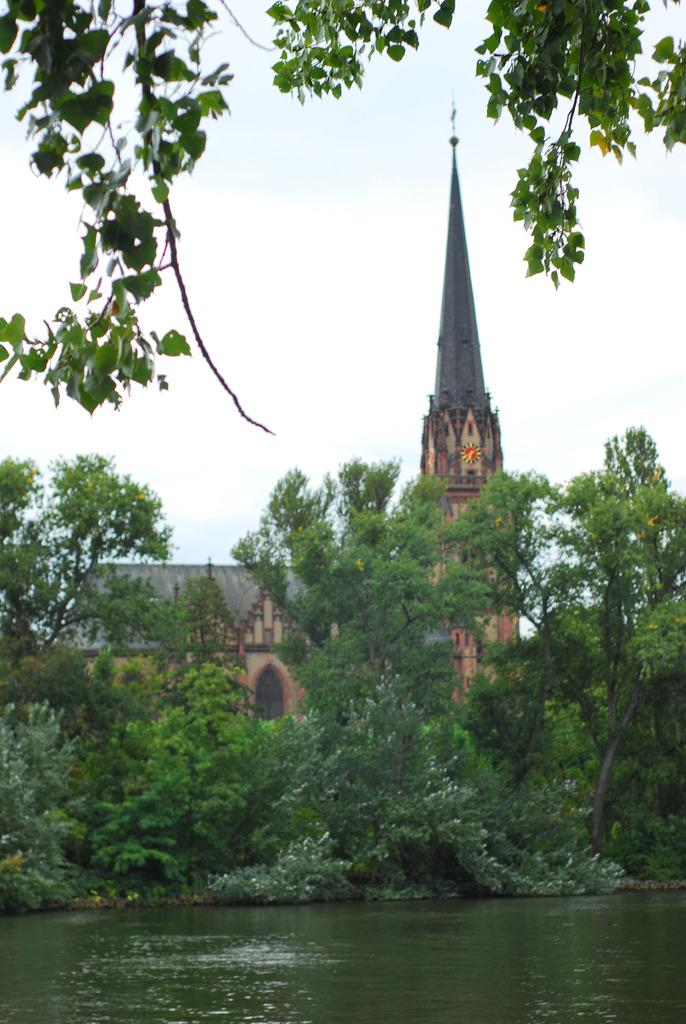What type of vegetation can be seen in the image? There are trees in the image. What body of water is visible at the bottom of the image? There is a lake visible at the bottom of the image. What type of structure can be seen in the background of the image? There is a steeple in the background of the image. What part of the natural environment is visible in the image? The sky is visible in the background of the image. Can you see any quicksand in the image? There is no quicksand present in the image. What type of shoes are the trees wearing in the image? Trees do not wear shoes, as they are not living beings capable of wearing clothing or accessories. 